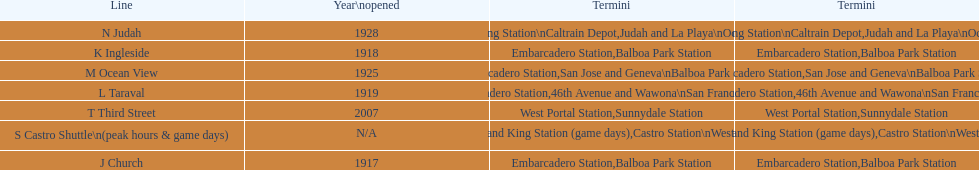On game days, which line do you want to use? S Castro Shuttle. Would you mind parsing the complete table? {'header': ['Line', 'Year\\nopened', 'Termini', 'Termini'], 'rows': [['N Judah', '1928', '4th and King Station\\nCaltrain Depot', 'Judah and La Playa\\nOcean Beach'], ['K Ingleside', '1918', 'Embarcadero Station', 'Balboa Park Station'], ['M Ocean View', '1925', 'Embarcadero Station', 'San Jose and Geneva\\nBalboa Park Station'], ['L Taraval', '1919', 'Embarcadero Station', '46th Avenue and Wawona\\nSan Francisco Zoo'], ['T Third Street', '2007', 'West Portal Station', 'Sunnydale Station'], ['S Castro Shuttle\\n(peak hours & game days)', 'N/A', 'Embarcadero Station\\n4th and King Station\xa0(game days)', 'Castro Station\\nWest Portal Station\xa0(game days)'], ['J Church', '1917', 'Embarcadero Station', 'Balboa Park Station']]} 